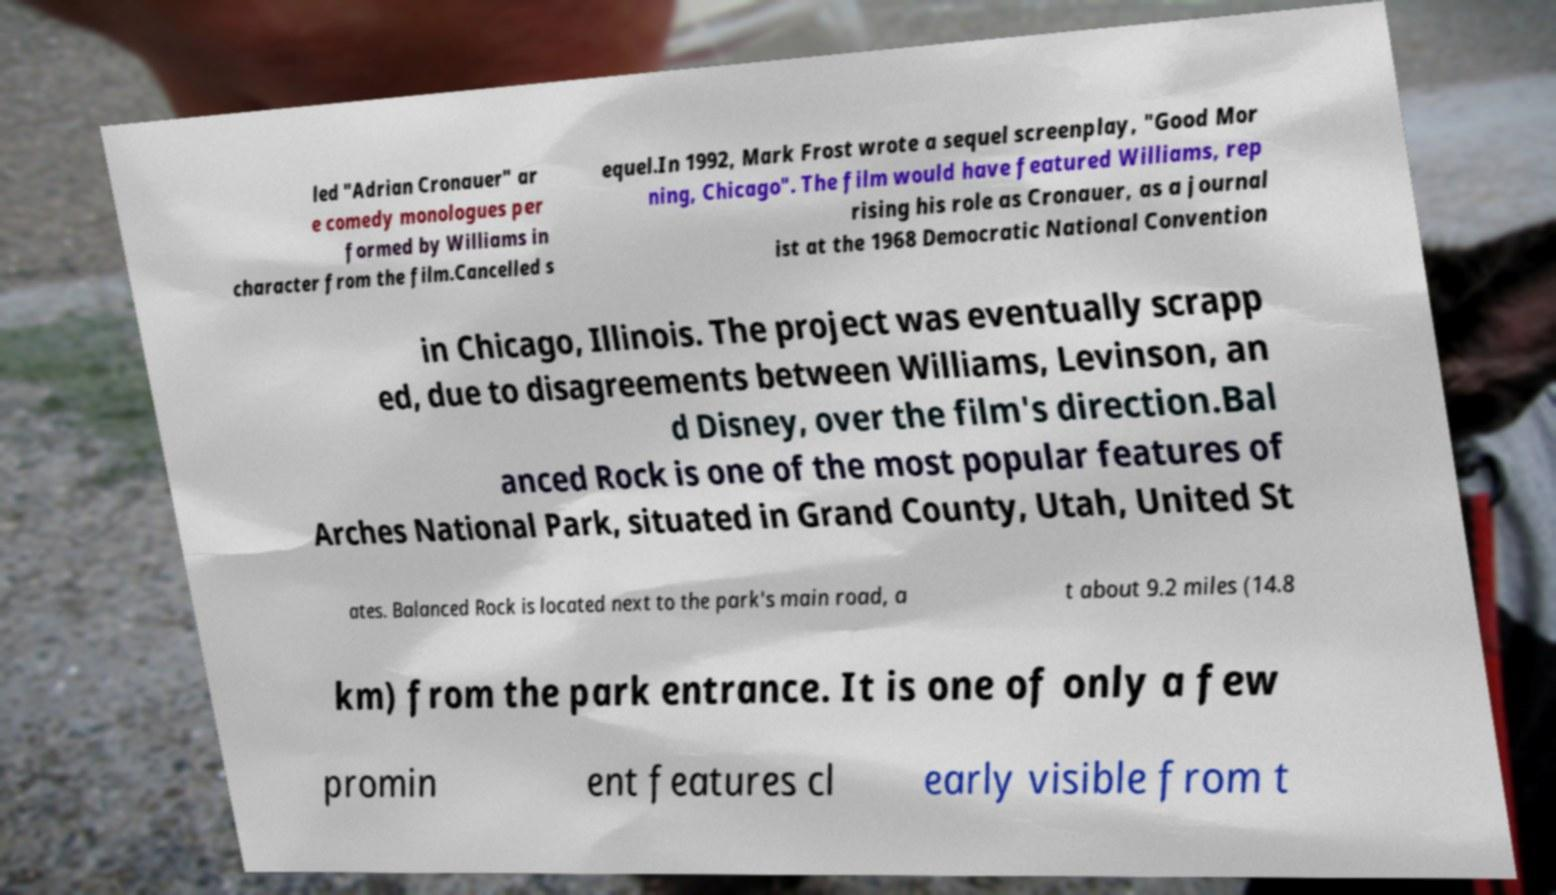Please read and relay the text visible in this image. What does it say? led "Adrian Cronauer" ar e comedy monologues per formed by Williams in character from the film.Cancelled s equel.In 1992, Mark Frost wrote a sequel screenplay, "Good Mor ning, Chicago". The film would have featured Williams, rep rising his role as Cronauer, as a journal ist at the 1968 Democratic National Convention in Chicago, Illinois. The project was eventually scrapp ed, due to disagreements between Williams, Levinson, an d Disney, over the film's direction.Bal anced Rock is one of the most popular features of Arches National Park, situated in Grand County, Utah, United St ates. Balanced Rock is located next to the park's main road, a t about 9.2 miles (14.8 km) from the park entrance. It is one of only a few promin ent features cl early visible from t 